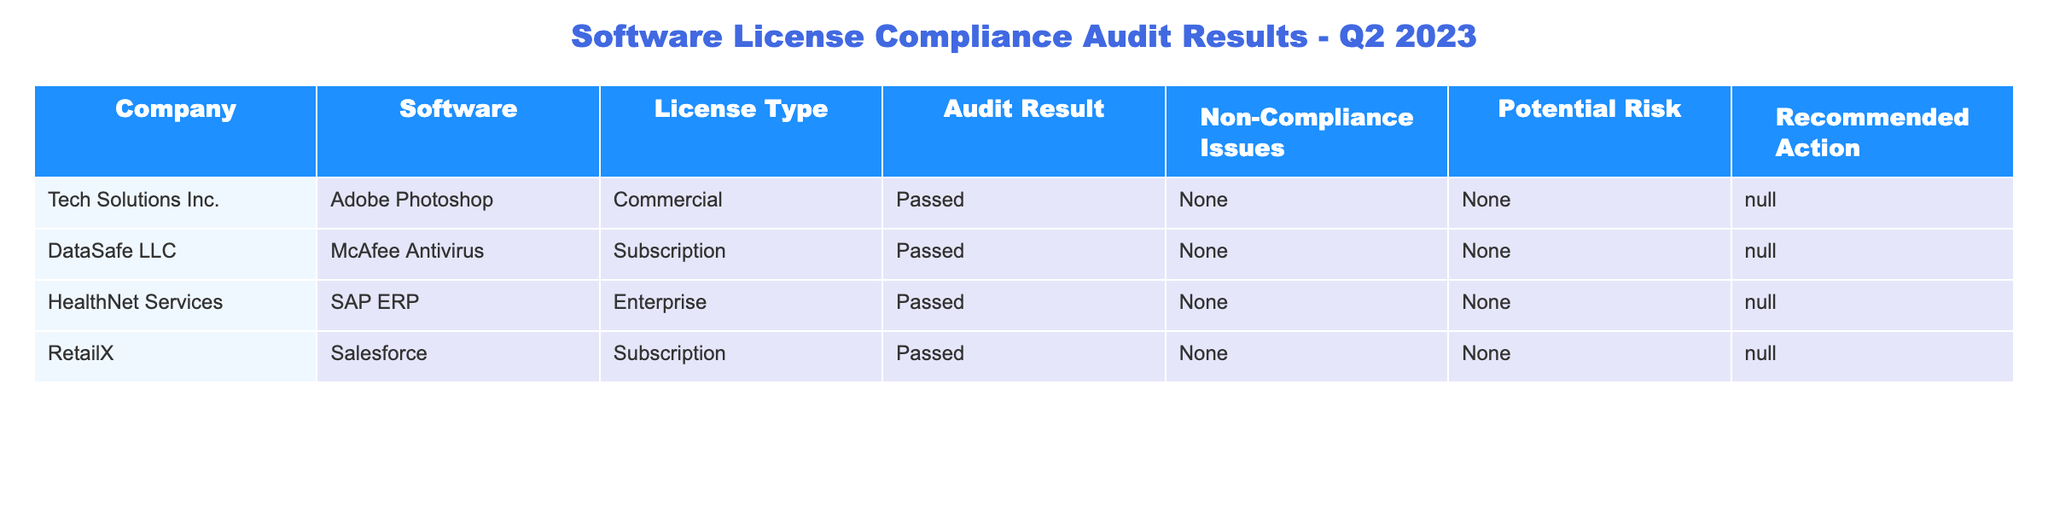What companies passed the software compliance audit in Q2 2023? By examining the "Audit Result" column in the table, all four companies (Tech Solutions Inc., DataSafe LLC, HealthNet Services, RetailX) show a "Passed" status.
Answer: Tech Solutions Inc., DataSafe LLC, HealthNet Services, RetailX How many software products listed in the audit have non-compliance issues? Looking at the "Non-Compliance Issues" column for each company, all entries are "None," indicating that there are no non-compliance issues.
Answer: 0 Did any of the companies have recommendations for action? The "Recommended Action" column for all companies shows "N/A," which means no recommendations for action were made for any company.
Answer: No What is the total number of software products listed in the audit? Count the entries in the table; there are four different software products listed for each company.
Answer: 4 Is the SAP ERP software associated with any potential risk? The "Potential Risk" column for HealthNet Services (SAP ERP) shows "None," indicating no potential risk is associated with this software.
Answer: No Which software company had an enterprise license type? Looking at the "License Type" column, HealthNet Services has an "Enterprise" license type for SAP ERP.
Answer: HealthNet Services What percentage of the companies passed the audit? Since all four companies passed the audit, that's 4 out of 4. To find the percentage, (4/4) * 100 = 100%.
Answer: 100% Which company uses McAfee Antivirus? By scanning the "Software" column alongside the "Company" column, DataSafe LLC is identified as the company using McAfee Antivirus.
Answer: DataSafe LLC Which software had the highest potential risk rating? The "Potential Risk" column shows "None" for all entries, indicating that no software has a higher risk rating.
Answer: None Which software company is using a subscription license type and passed the audit? In the table, both DataSafe LLC (McAfee Antivirus) and RetailX (Salesforce) are using a subscription license type and have passed the audit.
Answer: DataSafe LLC, RetailX How many organizations are included in the audit results overall? Count the unique organizations listed in the "Company" column; there are four organizations in total in the table.
Answer: 4 